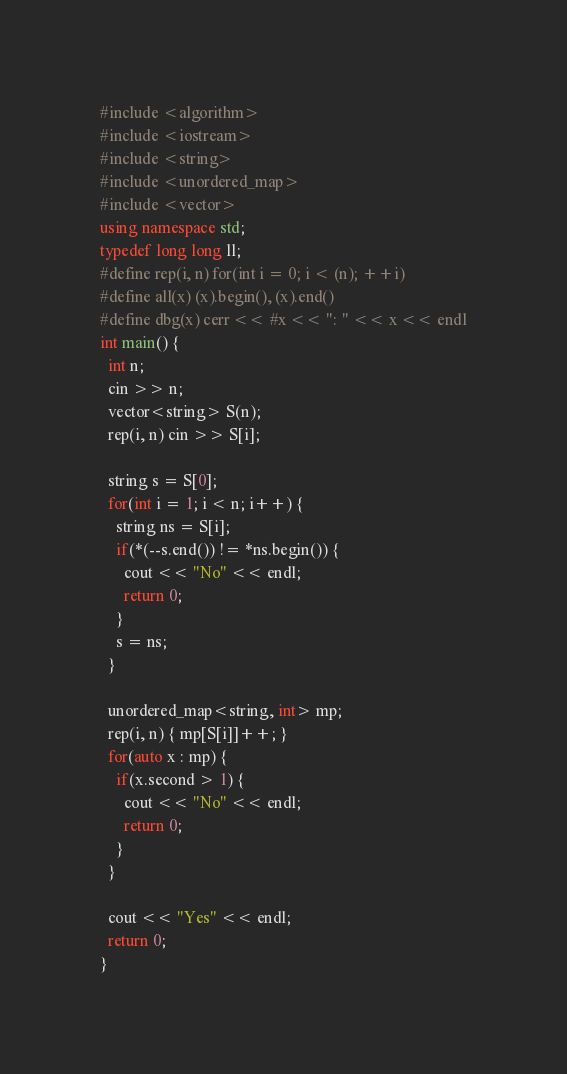Convert code to text. <code><loc_0><loc_0><loc_500><loc_500><_C++_>#include <algorithm>
#include <iostream>
#include <string>
#include <unordered_map>
#include <vector>
using namespace std;
typedef long long ll;
#define rep(i, n) for(int i = 0; i < (n); ++i)
#define all(x) (x).begin(), (x).end()
#define dbg(x) cerr << #x << ": " << x << endl
int main() {
  int n;
  cin >> n;
  vector<string> S(n);
  rep(i, n) cin >> S[i];

  string s = S[0];
  for(int i = 1; i < n; i++) {
    string ns = S[i];
    if(*(--s.end()) != *ns.begin()) {
      cout << "No" << endl;
      return 0;
    }
    s = ns;
  }

  unordered_map<string, int> mp;
  rep(i, n) { mp[S[i]]++; }
  for(auto x : mp) {
    if(x.second > 1) {
      cout << "No" << endl;
      return 0;
    }
  }

  cout << "Yes" << endl;
  return 0;
}</code> 